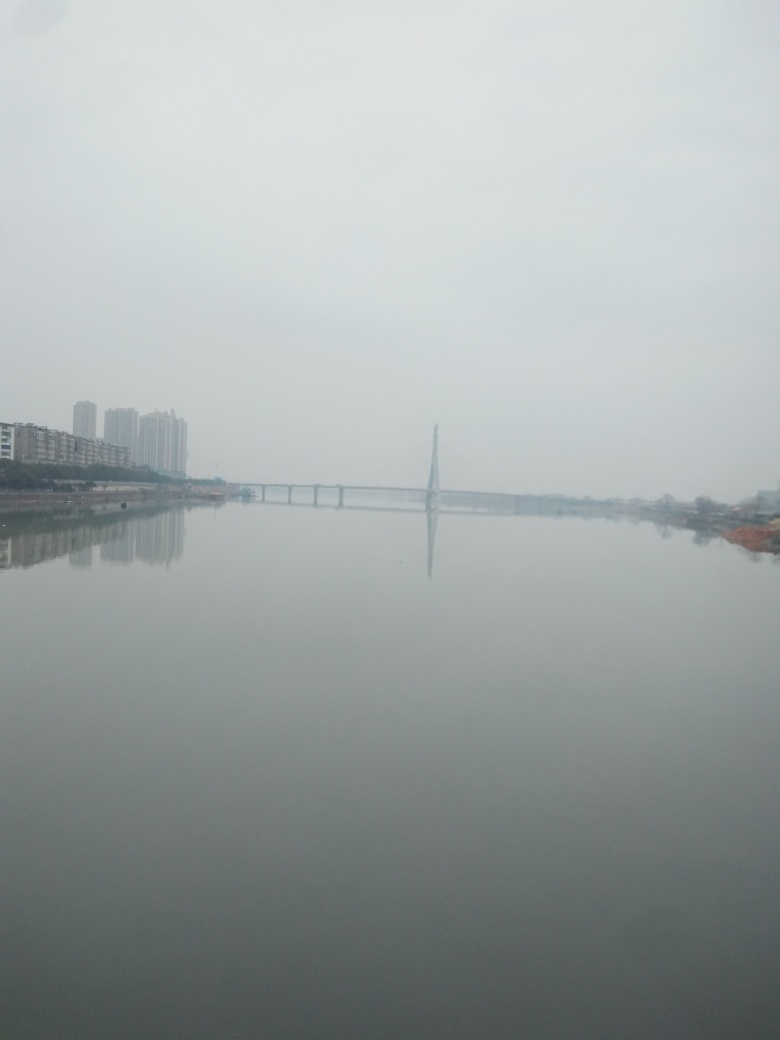Can you tell me more about the weather conditions when this photo was taken? The photo appears to have been taken on an overcast day with low visibility, potentially indicating fog, mist, or a high level of air pollution which obscures the surroundings and gives the image a muted appearance. 